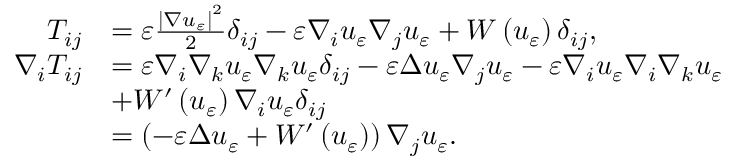<formula> <loc_0><loc_0><loc_500><loc_500>\begin{array} { r l } { T _ { i j } } & { = \varepsilon \frac { \left | \nabla u _ { \varepsilon } \right | ^ { 2 } } { 2 } \delta _ { i j } - \varepsilon \nabla _ { i } u _ { \varepsilon } \nabla _ { j } u _ { \varepsilon } + W \left ( u _ { \varepsilon } \right ) \delta _ { i j } , } \\ { \nabla _ { i } T _ { i j } } & { = \varepsilon \nabla _ { i } \nabla _ { k } u _ { \varepsilon } \nabla _ { k } u _ { \varepsilon } \delta _ { i j } - \varepsilon \Delta u _ { \varepsilon } \nabla _ { j } u _ { \varepsilon } - \varepsilon \nabla _ { i } u _ { \varepsilon } \nabla _ { i } \nabla _ { k } u _ { \varepsilon } } \\ & { + W ^ { \prime } \left ( u _ { \varepsilon } \right ) \nabla _ { i } u _ { \varepsilon } \delta _ { i j } } \\ & { = \left ( - \varepsilon \Delta u _ { \varepsilon } + W ^ { \prime } \left ( u _ { \varepsilon } \right ) \right ) \nabla _ { j } u _ { \varepsilon } . } \end{array}</formula> 